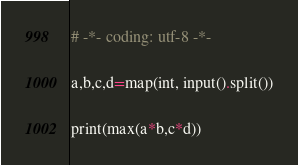Convert code to text. <code><loc_0><loc_0><loc_500><loc_500><_Python_># -*- coding: utf-8 -*-

a,b,c,d=map(int, input().split())

print(max(a*b,c*d))</code> 